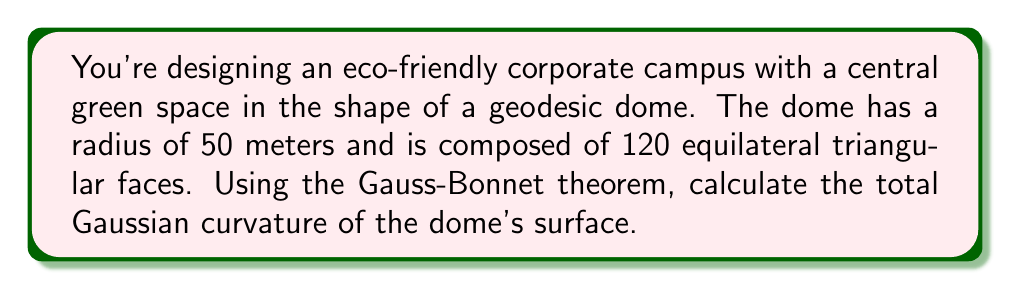What is the answer to this math problem? Let's approach this step-by-step:

1) The Gauss-Bonnet theorem states that for a closed surface:

   $$\int\int_S K dA + \int_{\partial S} k_g ds + \sum_{i=1}^n \alpha_i = 2\pi\chi(S)$$

   where $K$ is the Gaussian curvature, $k_g$ is the geodesic curvature, $\alpha_i$ are the exterior angles, and $\chi(S)$ is the Euler characteristic.

2) For a closed surface like our geodesic dome, there is no boundary, so the second term is zero.

3) The Euler characteristic for a sphere (which our dome approximates) is 2.

4) Our dome is composed of 120 equilateral triangles. In a geodesic dome, these triangles are slightly curved to fit the spherical surface.

5) At each vertex where triangles meet, the sum of the angles is slightly less than $2\pi$, creating a small exterior angle. These exterior angles sum to $4\pi$ for a sphere.

6) Substituting into the Gauss-Bonnet theorem:

   $$\int\int_S K dA + 4\pi = 2\pi(2)$$

7) Solving for the total Gaussian curvature:

   $$\int\int_S K dA = 4\pi - 4\pi = 0$$

8) This result is consistent with the fact that the total Gaussian curvature of a sphere is independent of its radius and always equals $4\pi$.
Answer: $4\pi$ square meters 